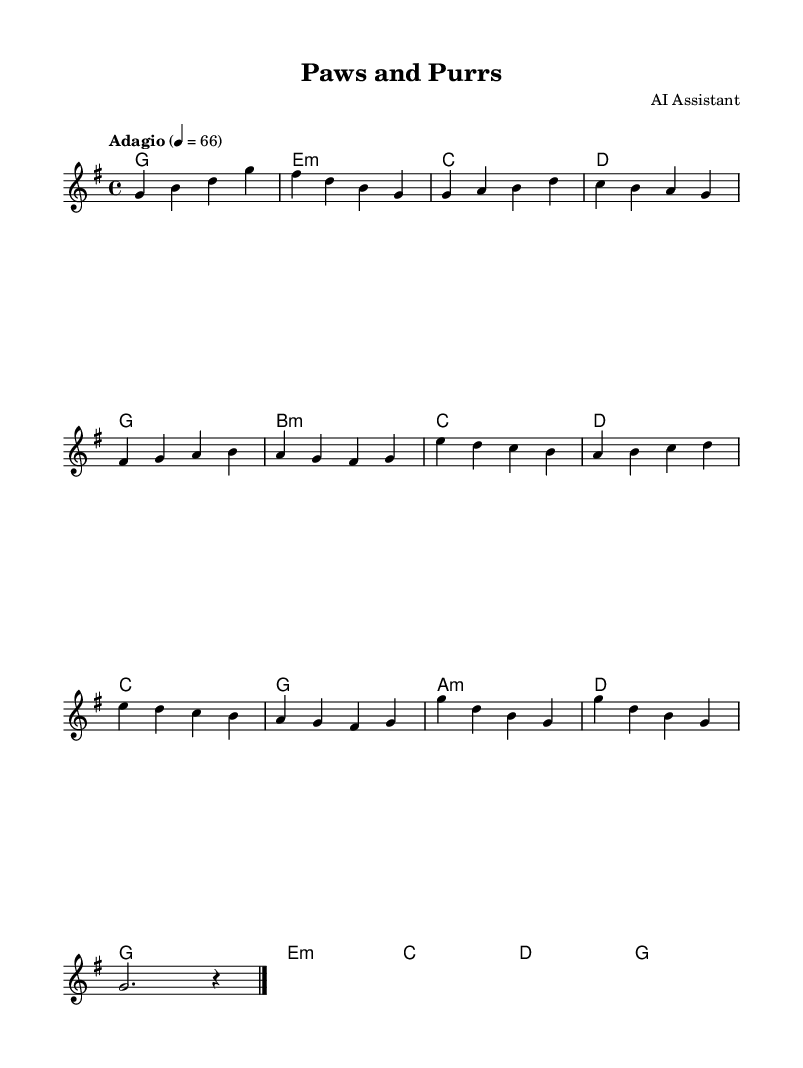What is the key signature of this music? The key signature is G major, which has one sharp (F#). This can be identified by looking at the key signature indicator at the beginning of the sheet music.
Answer: G major What is the time signature of this piece? The time signature is 4/4, indicated both at the beginning of the score. This means there are four beats in each measure, and the quarter note gets one beat.
Answer: 4/4 What is the tempo marking specified? The tempo marking is "Adagio," which indicates a slow tempo. This is specified at the beginning, indicating the style and speed to be used when playing the piece.
Answer: Adagio How many sections does the music have? The music has three distinct sections: an Intro, an A Section, and a B Section followed by an Outro. This can be inferred from the layout and structure of the music, where sections are clearly separated.
Answer: Three What is the first note of the melody? The first note of the melody is G. This can be determined by looking at the melody line at the start of the sheet music.
Answer: G Which chord follows the first measure? The chord following the first measure is E minor. This can be seen in the chord notation below the staff, where the first chord shown after the initial measure is E minor.
Answer: E minor What type of music is this sheet composed for? This sheet is composed for calm ambient soundtracks suitable for veterinary waiting rooms. This is inferred from the melody's gentle character and tempo, designed to provide a soothing atmosphere for pets and their owners.
Answer: Ambient soundtrack 